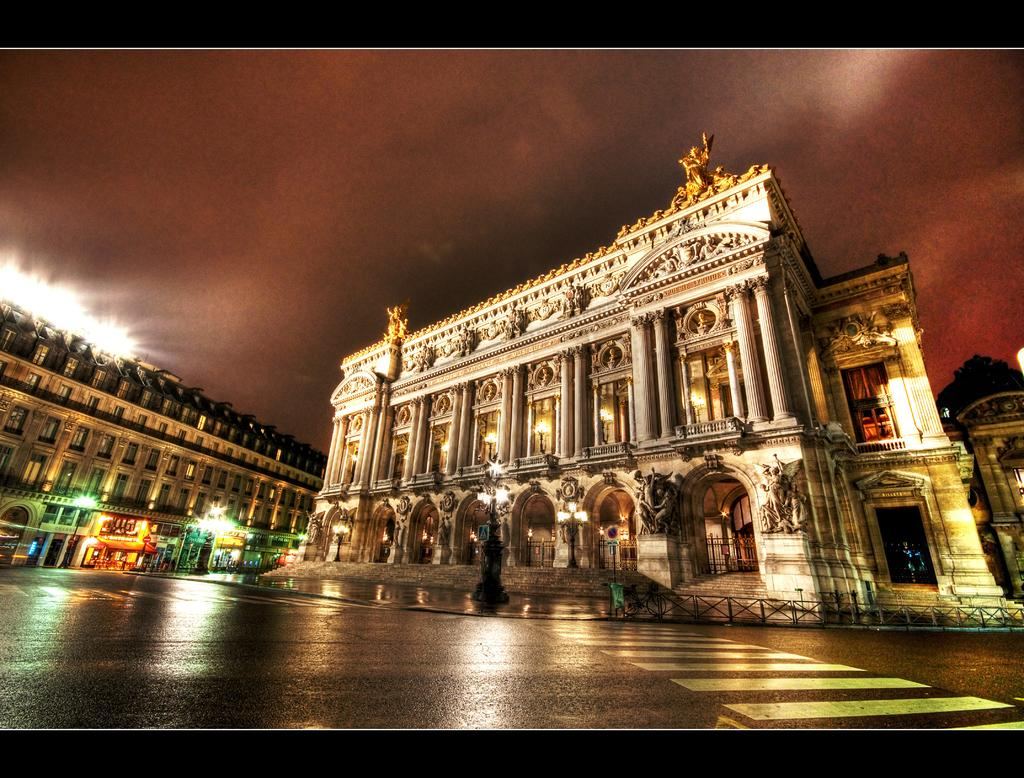What type of structures can be seen in the image? There are buildings in the image. What else is visible in the image besides the buildings? There are lights, statues, the sky, a road, and the top and bottom of the image are dark. Can you describe the lighting in the image? There are lights visible in the image. What is the condition of the sky in the image? The sky is visible in the image. What type of pathway is present in the image? There is a road in the image. What type of government is depicted in the image? There is no depiction of a government in the image. How many bits can be seen in the image? There are no bits present in the image. 